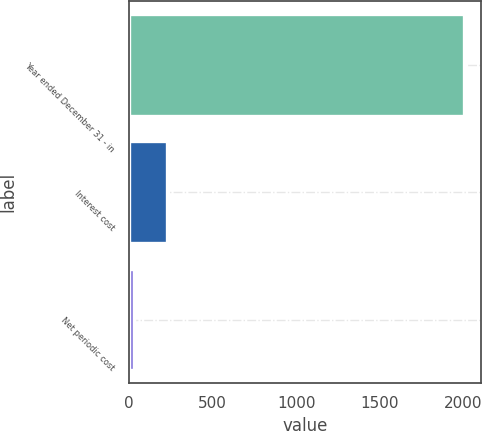Convert chart to OTSL. <chart><loc_0><loc_0><loc_500><loc_500><bar_chart><fcel>Year ended December 31 - in<fcel>Interest cost<fcel>Net periodic cost<nl><fcel>2007<fcel>227.7<fcel>30<nl></chart> 